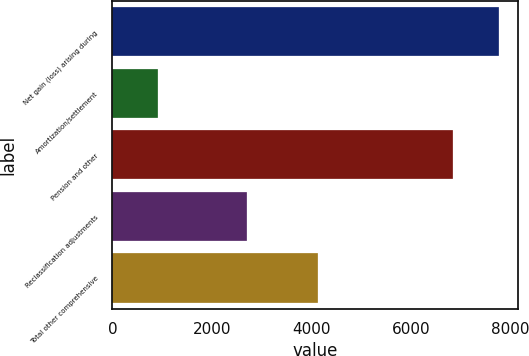Convert chart. <chart><loc_0><loc_0><loc_500><loc_500><bar_chart><fcel>Net gain (loss) arising during<fcel>Amortization/settlement<fcel>Pension and other<fcel>Reclassification adjustments<fcel>Total other comprehensive<nl><fcel>7767<fcel>915<fcel>6852<fcel>2713<fcel>4139<nl></chart> 